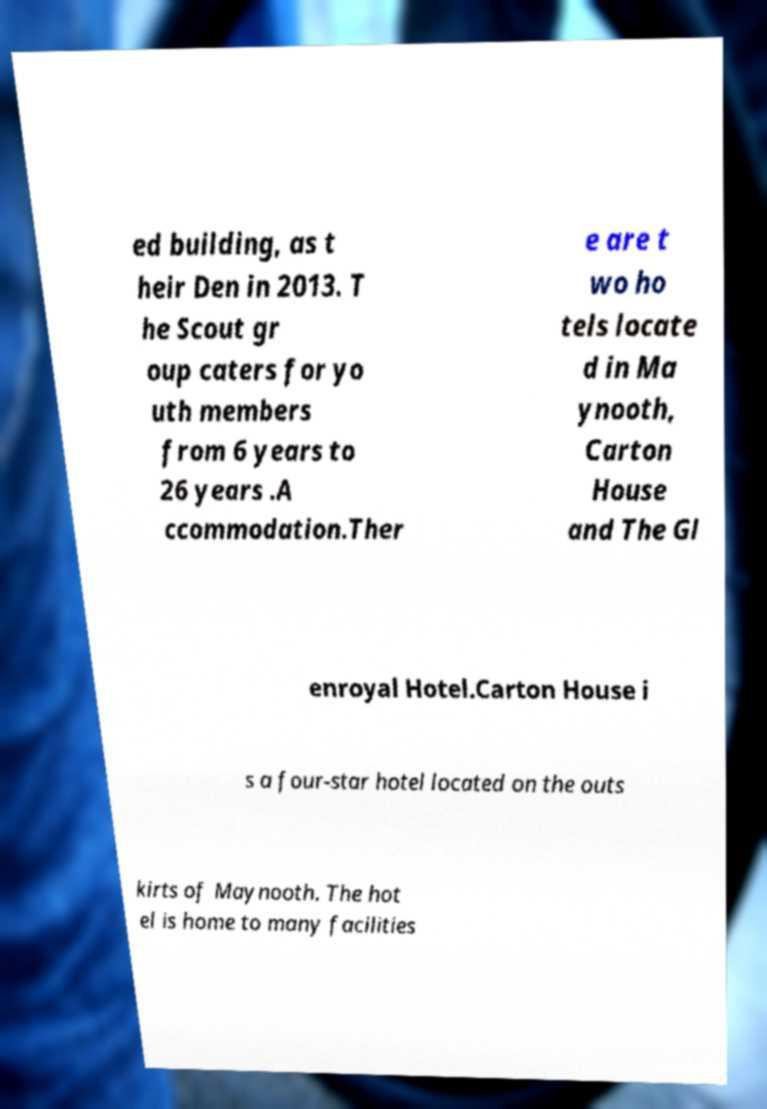Could you extract and type out the text from this image? ed building, as t heir Den in 2013. T he Scout gr oup caters for yo uth members from 6 years to 26 years .A ccommodation.Ther e are t wo ho tels locate d in Ma ynooth, Carton House and The Gl enroyal Hotel.Carton House i s a four-star hotel located on the outs kirts of Maynooth. The hot el is home to many facilities 